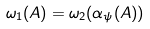Convert formula to latex. <formula><loc_0><loc_0><loc_500><loc_500>\omega _ { 1 } ( A ) = \omega _ { 2 } ( \alpha _ { \psi } ( A ) )</formula> 